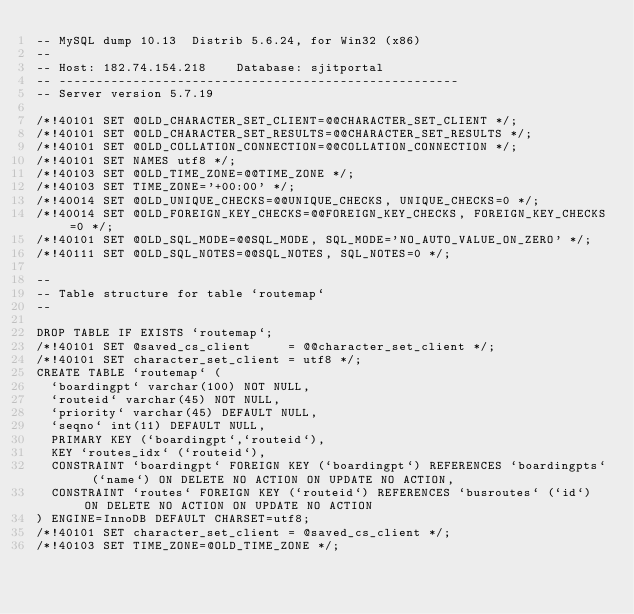<code> <loc_0><loc_0><loc_500><loc_500><_SQL_>-- MySQL dump 10.13  Distrib 5.6.24, for Win32 (x86)
--
-- Host: 182.74.154.218    Database: sjitportal
-- ------------------------------------------------------
-- Server version	5.7.19

/*!40101 SET @OLD_CHARACTER_SET_CLIENT=@@CHARACTER_SET_CLIENT */;
/*!40101 SET @OLD_CHARACTER_SET_RESULTS=@@CHARACTER_SET_RESULTS */;
/*!40101 SET @OLD_COLLATION_CONNECTION=@@COLLATION_CONNECTION */;
/*!40101 SET NAMES utf8 */;
/*!40103 SET @OLD_TIME_ZONE=@@TIME_ZONE */;
/*!40103 SET TIME_ZONE='+00:00' */;
/*!40014 SET @OLD_UNIQUE_CHECKS=@@UNIQUE_CHECKS, UNIQUE_CHECKS=0 */;
/*!40014 SET @OLD_FOREIGN_KEY_CHECKS=@@FOREIGN_KEY_CHECKS, FOREIGN_KEY_CHECKS=0 */;
/*!40101 SET @OLD_SQL_MODE=@@SQL_MODE, SQL_MODE='NO_AUTO_VALUE_ON_ZERO' */;
/*!40111 SET @OLD_SQL_NOTES=@@SQL_NOTES, SQL_NOTES=0 */;

--
-- Table structure for table `routemap`
--

DROP TABLE IF EXISTS `routemap`;
/*!40101 SET @saved_cs_client     = @@character_set_client */;
/*!40101 SET character_set_client = utf8 */;
CREATE TABLE `routemap` (
  `boardingpt` varchar(100) NOT NULL,
  `routeid` varchar(45) NOT NULL,
  `priority` varchar(45) DEFAULT NULL,
  `seqno` int(11) DEFAULT NULL,
  PRIMARY KEY (`boardingpt`,`routeid`),
  KEY `routes_idx` (`routeid`),
  CONSTRAINT `boardingpt` FOREIGN KEY (`boardingpt`) REFERENCES `boardingpts` (`name`) ON DELETE NO ACTION ON UPDATE NO ACTION,
  CONSTRAINT `routes` FOREIGN KEY (`routeid`) REFERENCES `busroutes` (`id`) ON DELETE NO ACTION ON UPDATE NO ACTION
) ENGINE=InnoDB DEFAULT CHARSET=utf8;
/*!40101 SET character_set_client = @saved_cs_client */;
/*!40103 SET TIME_ZONE=@OLD_TIME_ZONE */;
</code> 